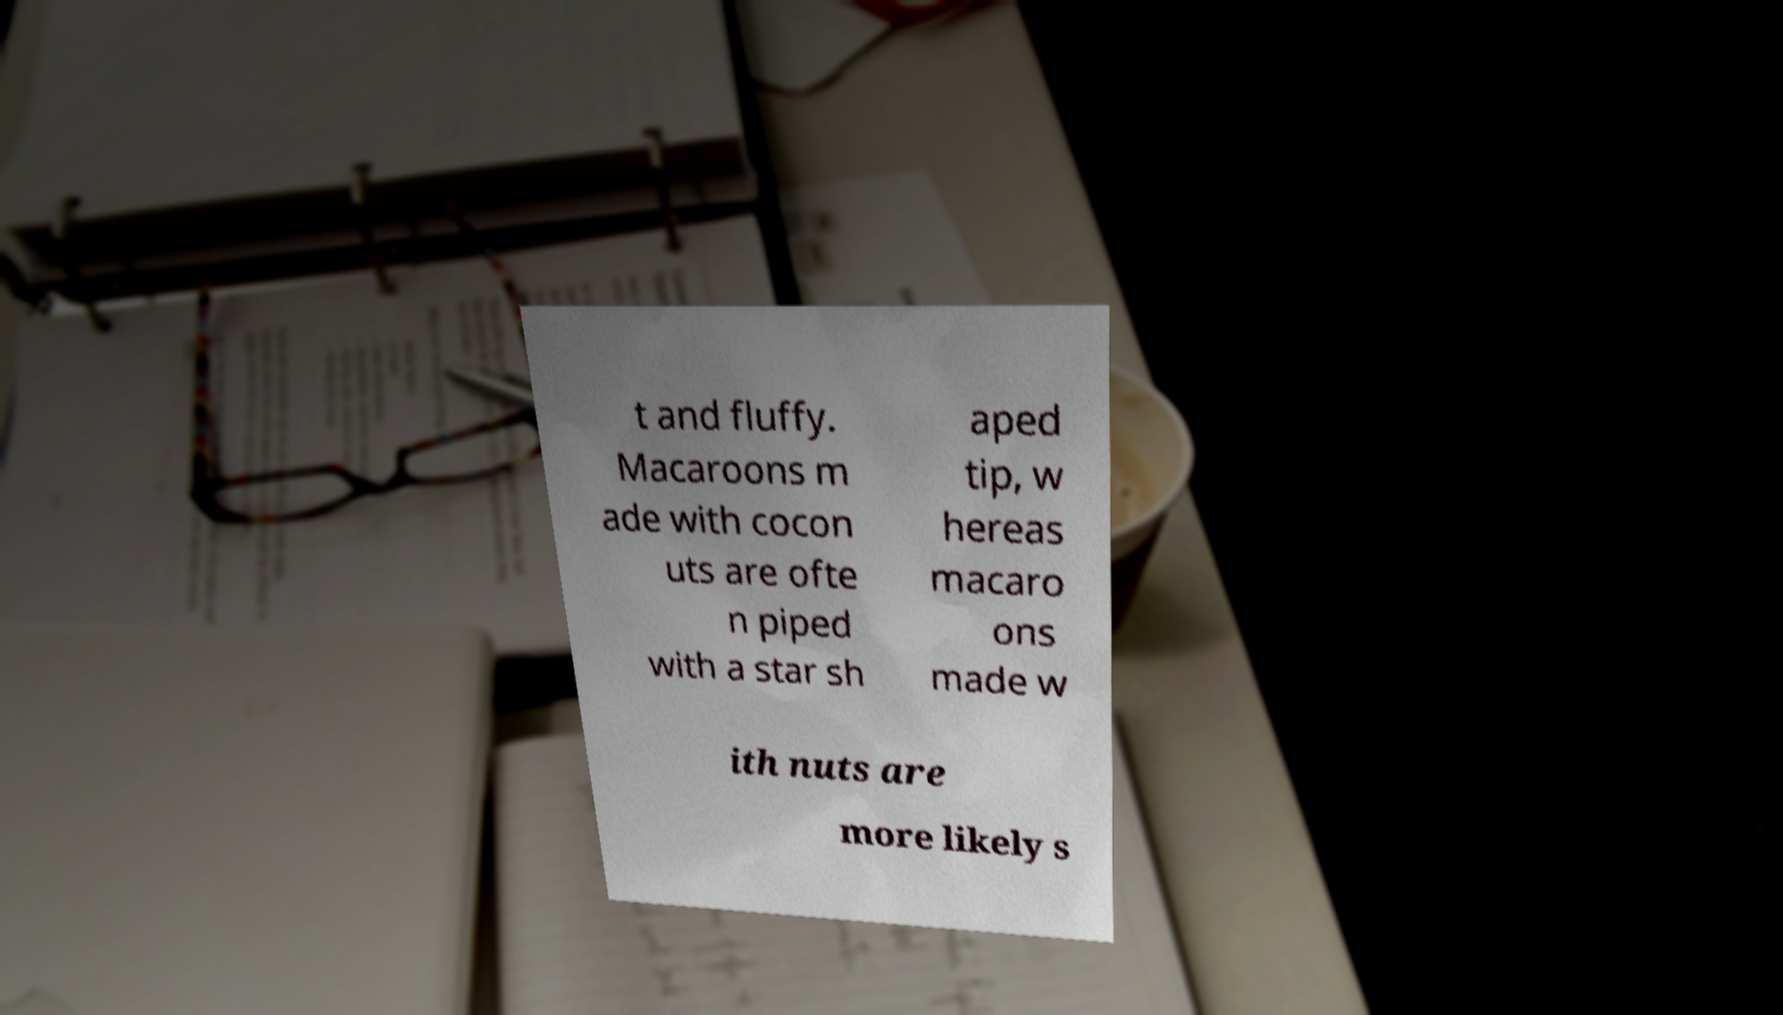There's text embedded in this image that I need extracted. Can you transcribe it verbatim? t and fluffy. Macaroons m ade with cocon uts are ofte n piped with a star sh aped tip, w hereas macaro ons made w ith nuts are more likely s 